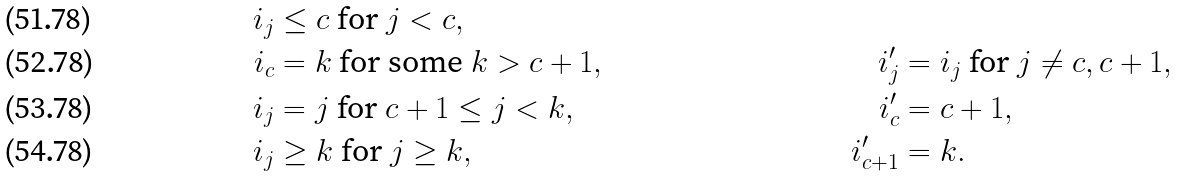Convert formula to latex. <formula><loc_0><loc_0><loc_500><loc_500>i _ { j } & \leq c \text { for } j < c , & & \\ i _ { c } & = k \text { for some } k > c + 1 , & i ^ { \prime } _ { j } & = i _ { j } \text { for } j \neq c , c + 1 , \\ i _ { j } & = j \text { for } c + 1 \leq j < k , & i ^ { \prime } _ { c } & = c + 1 , \\ i _ { j } & \geq k \text { for } j \geq k , & i ^ { \prime } _ { c + 1 } & = k .</formula> 